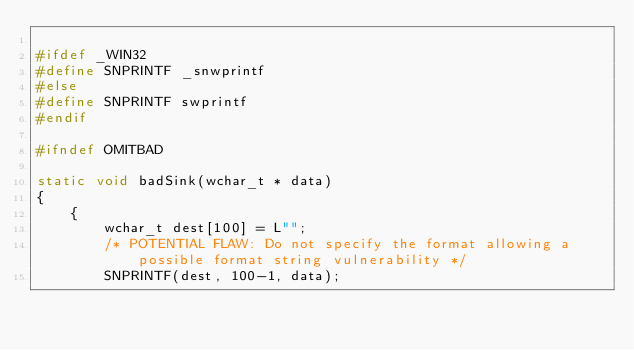<code> <loc_0><loc_0><loc_500><loc_500><_C_>
#ifdef _WIN32
#define SNPRINTF _snwprintf
#else
#define SNPRINTF swprintf
#endif

#ifndef OMITBAD

static void badSink(wchar_t * data)
{
    {
        wchar_t dest[100] = L"";
        /* POTENTIAL FLAW: Do not specify the format allowing a possible format string vulnerability */
        SNPRINTF(dest, 100-1, data);</code> 